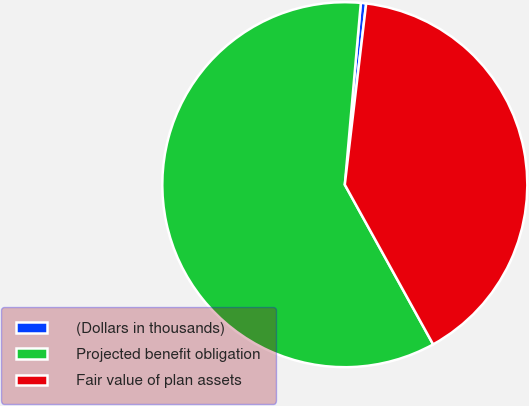Convert chart. <chart><loc_0><loc_0><loc_500><loc_500><pie_chart><fcel>(Dollars in thousands)<fcel>Projected benefit obligation<fcel>Fair value of plan assets<nl><fcel>0.47%<fcel>59.44%<fcel>40.09%<nl></chart> 